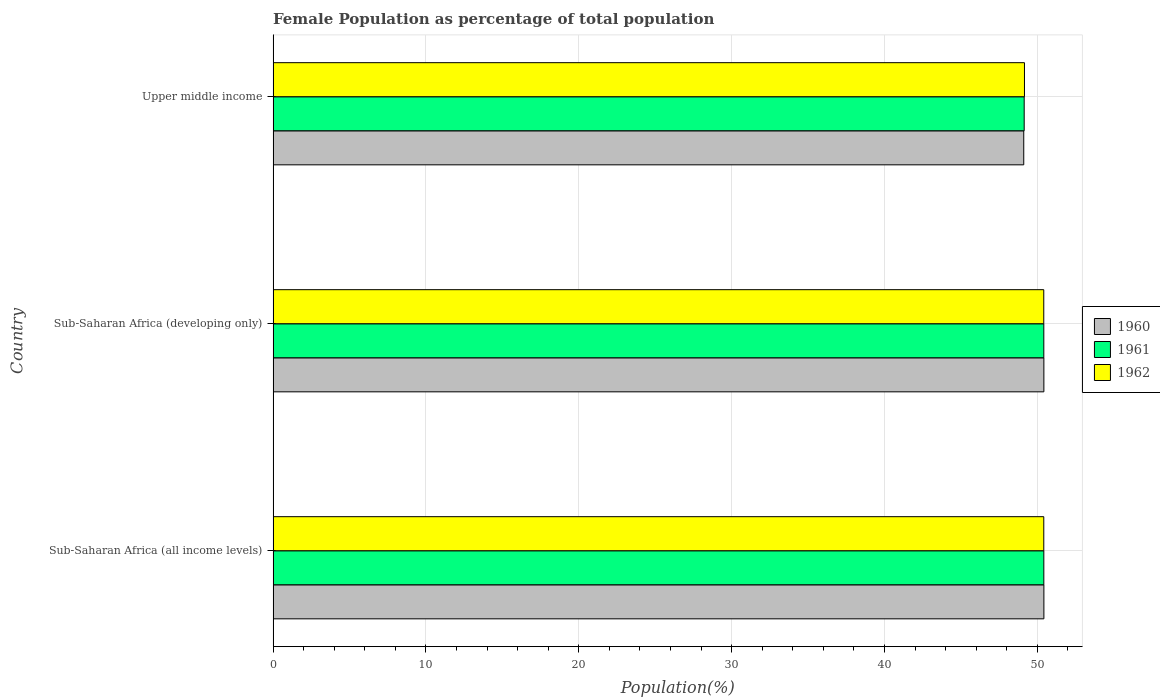How many different coloured bars are there?
Your answer should be very brief. 3. How many groups of bars are there?
Offer a terse response. 3. Are the number of bars on each tick of the Y-axis equal?
Keep it short and to the point. Yes. How many bars are there on the 2nd tick from the top?
Your response must be concise. 3. How many bars are there on the 3rd tick from the bottom?
Make the answer very short. 3. What is the label of the 2nd group of bars from the top?
Provide a short and direct response. Sub-Saharan Africa (developing only). In how many cases, is the number of bars for a given country not equal to the number of legend labels?
Offer a very short reply. 0. What is the female population in in 1961 in Sub-Saharan Africa (all income levels)?
Provide a short and direct response. 50.42. Across all countries, what is the maximum female population in in 1962?
Your answer should be very brief. 50.42. Across all countries, what is the minimum female population in in 1962?
Provide a short and direct response. 49.16. In which country was the female population in in 1961 maximum?
Make the answer very short. Sub-Saharan Africa (all income levels). In which country was the female population in in 1961 minimum?
Your response must be concise. Upper middle income. What is the total female population in in 1961 in the graph?
Keep it short and to the point. 149.99. What is the difference between the female population in in 1961 in Sub-Saharan Africa (all income levels) and that in Upper middle income?
Make the answer very short. 1.28. What is the difference between the female population in in 1962 in Upper middle income and the female population in in 1961 in Sub-Saharan Africa (developing only)?
Give a very brief answer. -1.27. What is the average female population in in 1961 per country?
Provide a succinct answer. 50. What is the difference between the female population in in 1960 and female population in in 1961 in Sub-Saharan Africa (all income levels)?
Your answer should be very brief. 0. In how many countries, is the female population in in 1961 greater than 16 %?
Your answer should be compact. 3. What is the ratio of the female population in in 1960 in Sub-Saharan Africa (all income levels) to that in Upper middle income?
Offer a very short reply. 1.03. What is the difference between the highest and the second highest female population in in 1961?
Give a very brief answer. 0. What is the difference between the highest and the lowest female population in in 1962?
Make the answer very short. 1.26. Is the sum of the female population in in 1962 in Sub-Saharan Africa (all income levels) and Sub-Saharan Africa (developing only) greater than the maximum female population in in 1960 across all countries?
Keep it short and to the point. Yes. Are all the bars in the graph horizontal?
Give a very brief answer. Yes. What is the difference between two consecutive major ticks on the X-axis?
Ensure brevity in your answer.  10. Are the values on the major ticks of X-axis written in scientific E-notation?
Provide a short and direct response. No. Where does the legend appear in the graph?
Your response must be concise. Center right. How many legend labels are there?
Provide a succinct answer. 3. How are the legend labels stacked?
Your answer should be very brief. Vertical. What is the title of the graph?
Keep it short and to the point. Female Population as percentage of total population. What is the label or title of the X-axis?
Ensure brevity in your answer.  Population(%). What is the label or title of the Y-axis?
Make the answer very short. Country. What is the Population(%) of 1960 in Sub-Saharan Africa (all income levels)?
Give a very brief answer. 50.43. What is the Population(%) in 1961 in Sub-Saharan Africa (all income levels)?
Your answer should be very brief. 50.42. What is the Population(%) in 1962 in Sub-Saharan Africa (all income levels)?
Ensure brevity in your answer.  50.42. What is the Population(%) in 1960 in Sub-Saharan Africa (developing only)?
Offer a very short reply. 50.43. What is the Population(%) in 1961 in Sub-Saharan Africa (developing only)?
Your answer should be very brief. 50.42. What is the Population(%) of 1962 in Sub-Saharan Africa (developing only)?
Provide a succinct answer. 50.42. What is the Population(%) of 1960 in Upper middle income?
Offer a very short reply. 49.11. What is the Population(%) in 1961 in Upper middle income?
Your answer should be compact. 49.14. What is the Population(%) of 1962 in Upper middle income?
Keep it short and to the point. 49.16. Across all countries, what is the maximum Population(%) in 1960?
Keep it short and to the point. 50.43. Across all countries, what is the maximum Population(%) in 1961?
Offer a terse response. 50.42. Across all countries, what is the maximum Population(%) in 1962?
Provide a succinct answer. 50.42. Across all countries, what is the minimum Population(%) in 1960?
Your answer should be compact. 49.11. Across all countries, what is the minimum Population(%) in 1961?
Provide a succinct answer. 49.14. Across all countries, what is the minimum Population(%) of 1962?
Your answer should be very brief. 49.16. What is the total Population(%) in 1960 in the graph?
Make the answer very short. 149.97. What is the total Population(%) of 1961 in the graph?
Your answer should be very brief. 149.99. What is the total Population(%) of 1962 in the graph?
Offer a very short reply. 150. What is the difference between the Population(%) of 1960 in Sub-Saharan Africa (all income levels) and that in Sub-Saharan Africa (developing only)?
Provide a succinct answer. 0. What is the difference between the Population(%) of 1961 in Sub-Saharan Africa (all income levels) and that in Sub-Saharan Africa (developing only)?
Provide a short and direct response. 0. What is the difference between the Population(%) in 1962 in Sub-Saharan Africa (all income levels) and that in Sub-Saharan Africa (developing only)?
Your answer should be compact. 0. What is the difference between the Population(%) in 1960 in Sub-Saharan Africa (all income levels) and that in Upper middle income?
Your answer should be very brief. 1.32. What is the difference between the Population(%) of 1961 in Sub-Saharan Africa (all income levels) and that in Upper middle income?
Offer a terse response. 1.28. What is the difference between the Population(%) of 1962 in Sub-Saharan Africa (all income levels) and that in Upper middle income?
Ensure brevity in your answer.  1.26. What is the difference between the Population(%) in 1960 in Sub-Saharan Africa (developing only) and that in Upper middle income?
Offer a very short reply. 1.32. What is the difference between the Population(%) in 1961 in Sub-Saharan Africa (developing only) and that in Upper middle income?
Offer a terse response. 1.28. What is the difference between the Population(%) in 1962 in Sub-Saharan Africa (developing only) and that in Upper middle income?
Your response must be concise. 1.26. What is the difference between the Population(%) of 1960 in Sub-Saharan Africa (all income levels) and the Population(%) of 1961 in Sub-Saharan Africa (developing only)?
Your response must be concise. 0.01. What is the difference between the Population(%) in 1960 in Sub-Saharan Africa (all income levels) and the Population(%) in 1962 in Sub-Saharan Africa (developing only)?
Provide a succinct answer. 0.01. What is the difference between the Population(%) in 1961 in Sub-Saharan Africa (all income levels) and the Population(%) in 1962 in Sub-Saharan Africa (developing only)?
Ensure brevity in your answer.  0. What is the difference between the Population(%) in 1960 in Sub-Saharan Africa (all income levels) and the Population(%) in 1961 in Upper middle income?
Your answer should be very brief. 1.29. What is the difference between the Population(%) of 1960 in Sub-Saharan Africa (all income levels) and the Population(%) of 1962 in Upper middle income?
Your answer should be compact. 1.27. What is the difference between the Population(%) in 1961 in Sub-Saharan Africa (all income levels) and the Population(%) in 1962 in Upper middle income?
Offer a terse response. 1.27. What is the difference between the Population(%) of 1960 in Sub-Saharan Africa (developing only) and the Population(%) of 1961 in Upper middle income?
Your answer should be very brief. 1.29. What is the difference between the Population(%) in 1960 in Sub-Saharan Africa (developing only) and the Population(%) in 1962 in Upper middle income?
Provide a succinct answer. 1.27. What is the difference between the Population(%) in 1961 in Sub-Saharan Africa (developing only) and the Population(%) in 1962 in Upper middle income?
Give a very brief answer. 1.27. What is the average Population(%) in 1960 per country?
Your response must be concise. 49.99. What is the average Population(%) in 1961 per country?
Ensure brevity in your answer.  50. What is the average Population(%) of 1962 per country?
Give a very brief answer. 50. What is the difference between the Population(%) of 1960 and Population(%) of 1961 in Sub-Saharan Africa (all income levels)?
Provide a succinct answer. 0. What is the difference between the Population(%) in 1960 and Population(%) in 1962 in Sub-Saharan Africa (all income levels)?
Provide a short and direct response. 0.01. What is the difference between the Population(%) of 1961 and Population(%) of 1962 in Sub-Saharan Africa (all income levels)?
Your response must be concise. 0. What is the difference between the Population(%) of 1960 and Population(%) of 1961 in Sub-Saharan Africa (developing only)?
Make the answer very short. 0. What is the difference between the Population(%) of 1960 and Population(%) of 1962 in Sub-Saharan Africa (developing only)?
Provide a succinct answer. 0.01. What is the difference between the Population(%) of 1961 and Population(%) of 1962 in Sub-Saharan Africa (developing only)?
Keep it short and to the point. 0. What is the difference between the Population(%) of 1960 and Population(%) of 1961 in Upper middle income?
Your answer should be very brief. -0.03. What is the difference between the Population(%) in 1960 and Population(%) in 1962 in Upper middle income?
Your answer should be compact. -0.05. What is the difference between the Population(%) in 1961 and Population(%) in 1962 in Upper middle income?
Give a very brief answer. -0.02. What is the ratio of the Population(%) of 1961 in Sub-Saharan Africa (all income levels) to that in Sub-Saharan Africa (developing only)?
Make the answer very short. 1. What is the ratio of the Population(%) in 1960 in Sub-Saharan Africa (all income levels) to that in Upper middle income?
Offer a terse response. 1.03. What is the ratio of the Population(%) of 1961 in Sub-Saharan Africa (all income levels) to that in Upper middle income?
Offer a terse response. 1.03. What is the ratio of the Population(%) in 1962 in Sub-Saharan Africa (all income levels) to that in Upper middle income?
Provide a short and direct response. 1.03. What is the ratio of the Population(%) in 1960 in Sub-Saharan Africa (developing only) to that in Upper middle income?
Your answer should be compact. 1.03. What is the ratio of the Population(%) in 1961 in Sub-Saharan Africa (developing only) to that in Upper middle income?
Provide a succinct answer. 1.03. What is the ratio of the Population(%) in 1962 in Sub-Saharan Africa (developing only) to that in Upper middle income?
Make the answer very short. 1.03. What is the difference between the highest and the second highest Population(%) of 1960?
Your answer should be compact. 0. What is the difference between the highest and the second highest Population(%) in 1961?
Your response must be concise. 0. What is the difference between the highest and the second highest Population(%) in 1962?
Offer a terse response. 0. What is the difference between the highest and the lowest Population(%) in 1960?
Give a very brief answer. 1.32. What is the difference between the highest and the lowest Population(%) of 1961?
Provide a succinct answer. 1.28. What is the difference between the highest and the lowest Population(%) in 1962?
Your answer should be compact. 1.26. 